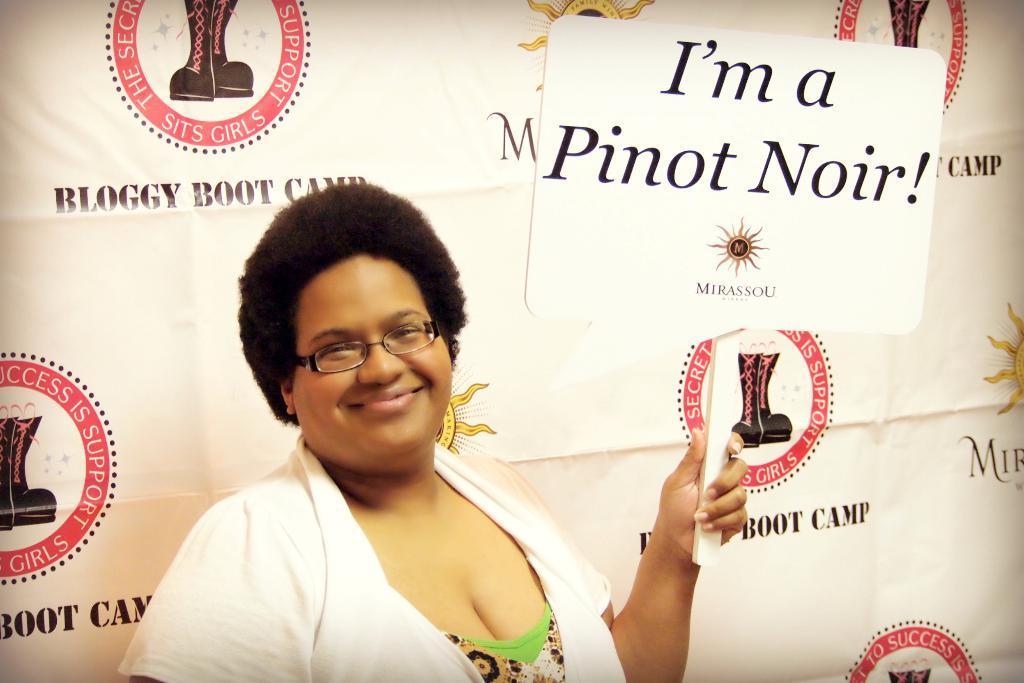In one or two sentences, can you explain what this image depicts? In the center of the image we can see a lady is standing and smiling and wearing coat, spectacles and holding a board. In the background of the image we can see a banner. 